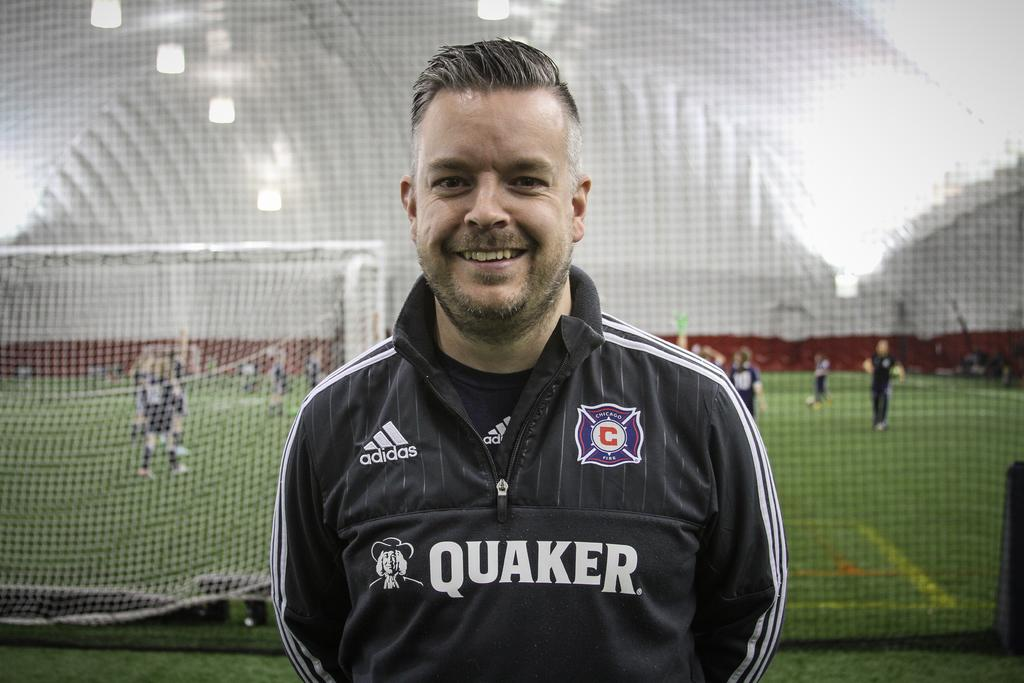Provide a one-sentence caption for the provided image. A soccer player is standing by a soccer game and wearing a Quaker sweater. 